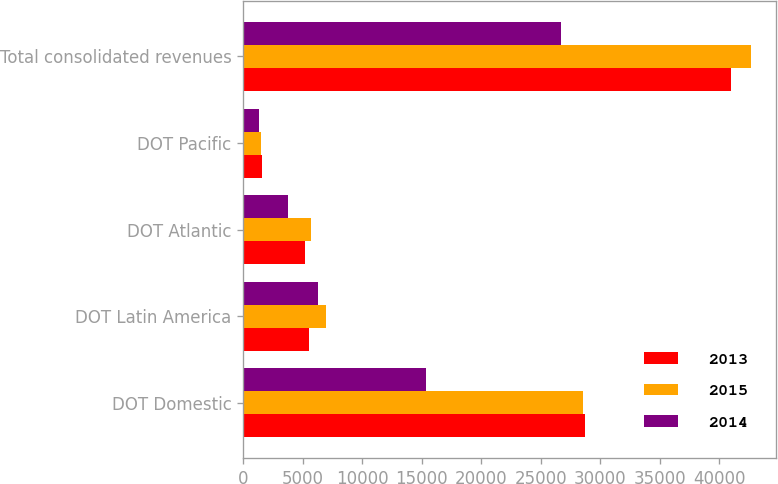Convert chart to OTSL. <chart><loc_0><loc_0><loc_500><loc_500><stacked_bar_chart><ecel><fcel>DOT Domestic<fcel>DOT Latin America<fcel>DOT Atlantic<fcel>DOT Pacific<fcel>Total consolidated revenues<nl><fcel>2013<fcel>28761<fcel>5539<fcel>5146<fcel>1544<fcel>40990<nl><fcel>2015<fcel>28568<fcel>6964<fcel>5652<fcel>1466<fcel>42650<nl><fcel>2014<fcel>15376<fcel>6288<fcel>3756<fcel>1323<fcel>26743<nl></chart> 